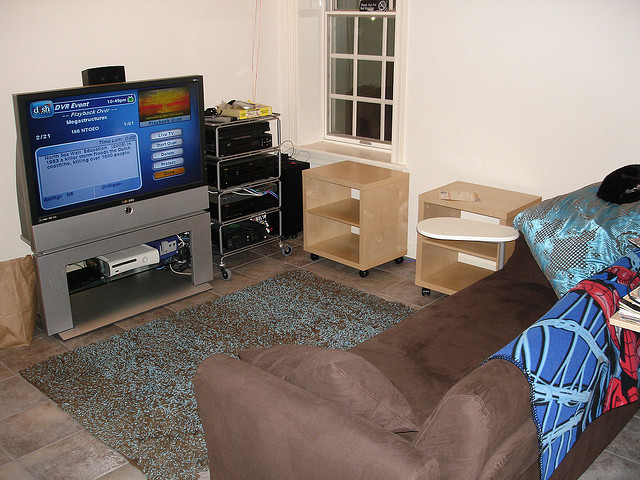Read and extract the text from this image. DVR 145 